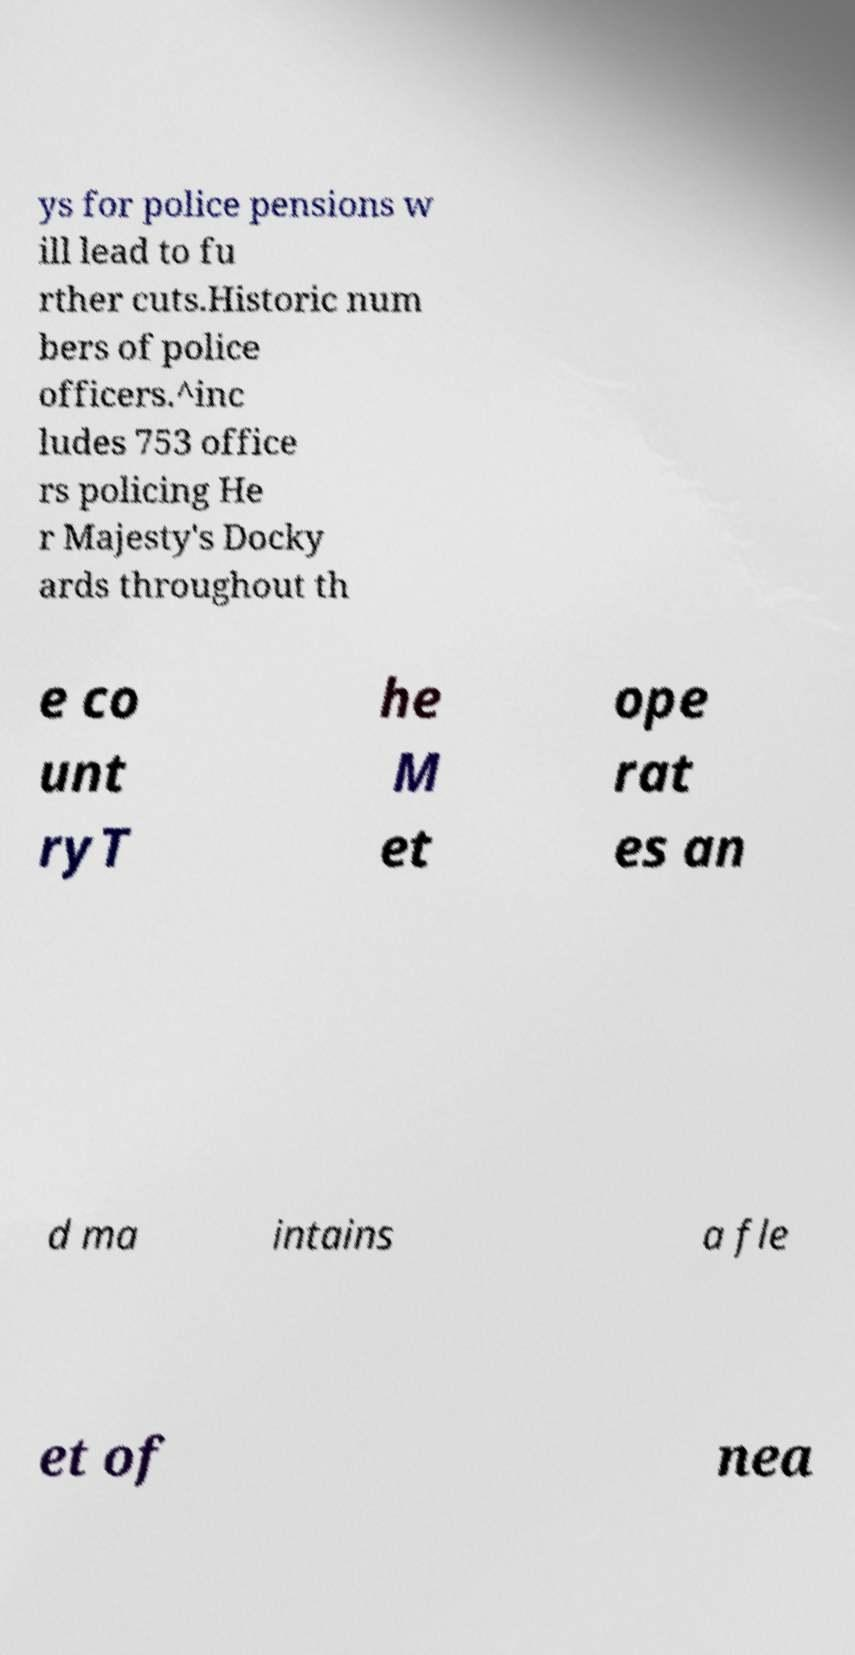There's text embedded in this image that I need extracted. Can you transcribe it verbatim? ys for police pensions w ill lead to fu rther cuts.Historic num bers of police officers.^inc ludes 753 office rs policing He r Majesty's Docky ards throughout th e co unt ryT he M et ope rat es an d ma intains a fle et of nea 